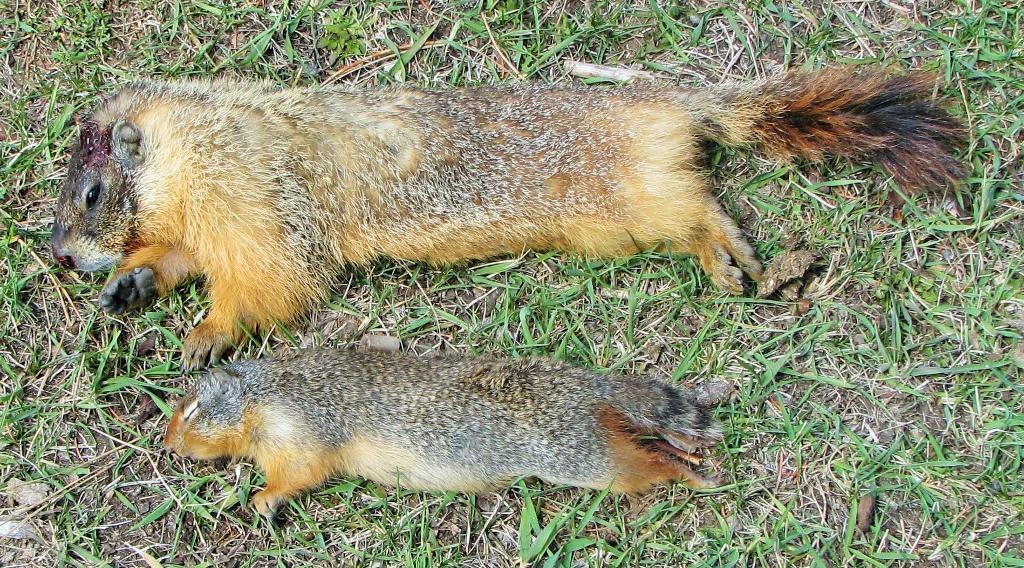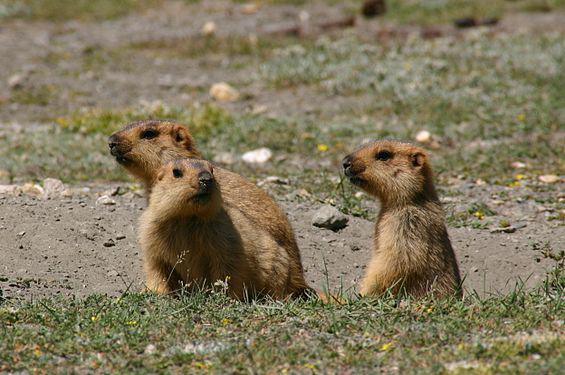The first image is the image on the left, the second image is the image on the right. Examine the images to the left and right. Is the description "In one image, an animal is eating." accurate? Answer yes or no. No. The first image is the image on the left, the second image is the image on the right. For the images shown, is this caption "The image on the right shows a single marmot standing on its back legs eating food." true? Answer yes or no. No. 